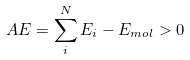Convert formula to latex. <formula><loc_0><loc_0><loc_500><loc_500>A E = \sum _ { i } ^ { N } E _ { i } - E _ { m o l } > 0</formula> 